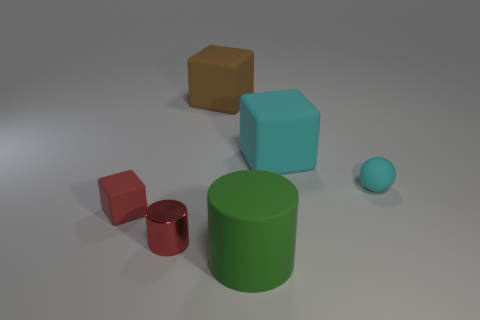There is a block that is the same color as the small shiny cylinder; what size is it?
Offer a terse response. Small. Is there anything else that has the same shape as the small cyan object?
Keep it short and to the point. No. Are the brown block behind the small cyan thing and the cube in front of the large cyan object made of the same material?
Provide a succinct answer. Yes. What is the material of the small red cube?
Offer a terse response. Rubber. What number of big cylinders have the same material as the small cyan sphere?
Offer a terse response. 1. How many rubber objects are either large spheres or cyan things?
Offer a terse response. 2. Do the tiny matte thing that is left of the cyan sphere and the small rubber thing on the right side of the big green matte cylinder have the same shape?
Make the answer very short. No. There is a big thing that is both to the left of the cyan rubber cube and behind the big green matte thing; what color is it?
Your response must be concise. Brown. Is the size of the cylinder on the left side of the brown rubber thing the same as the brown cube on the left side of the ball?
Provide a succinct answer. No. How many big objects have the same color as the matte sphere?
Your answer should be very brief. 1. 